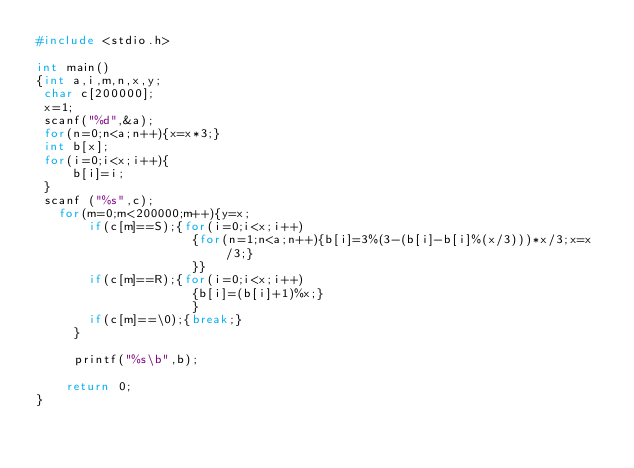Convert code to text. <code><loc_0><loc_0><loc_500><loc_500><_C_>#include <stdio.h>

int main()
{int a,i,m,n,x,y;
 char c[200000];
 x=1;
 scanf("%d",&a);
 for(n=0;n<a;n++){x=x*3;}
 int b[x];
 for(i=0;i<x;i++){
     b[i]=i;
 }
 scanf ("%s",c);
   for(m=0;m<200000;m++){y=x;
       if(c[m]==S);{for(i=0;i<x;i++)
                     {for(n=1;n<a;n++){b[i]=3%(3-(b[i]-b[i]%(x/3)))*x/3;x=x/3;}
                     }}
       if(c[m]==R);{for(i=0;i<x;i++)
                     {b[i]=(b[i]+1)%x;}
                     }
       if(c[m]==\0);{break;}
     }
     
     printf("%s\b",b);

    return 0;
}</code> 